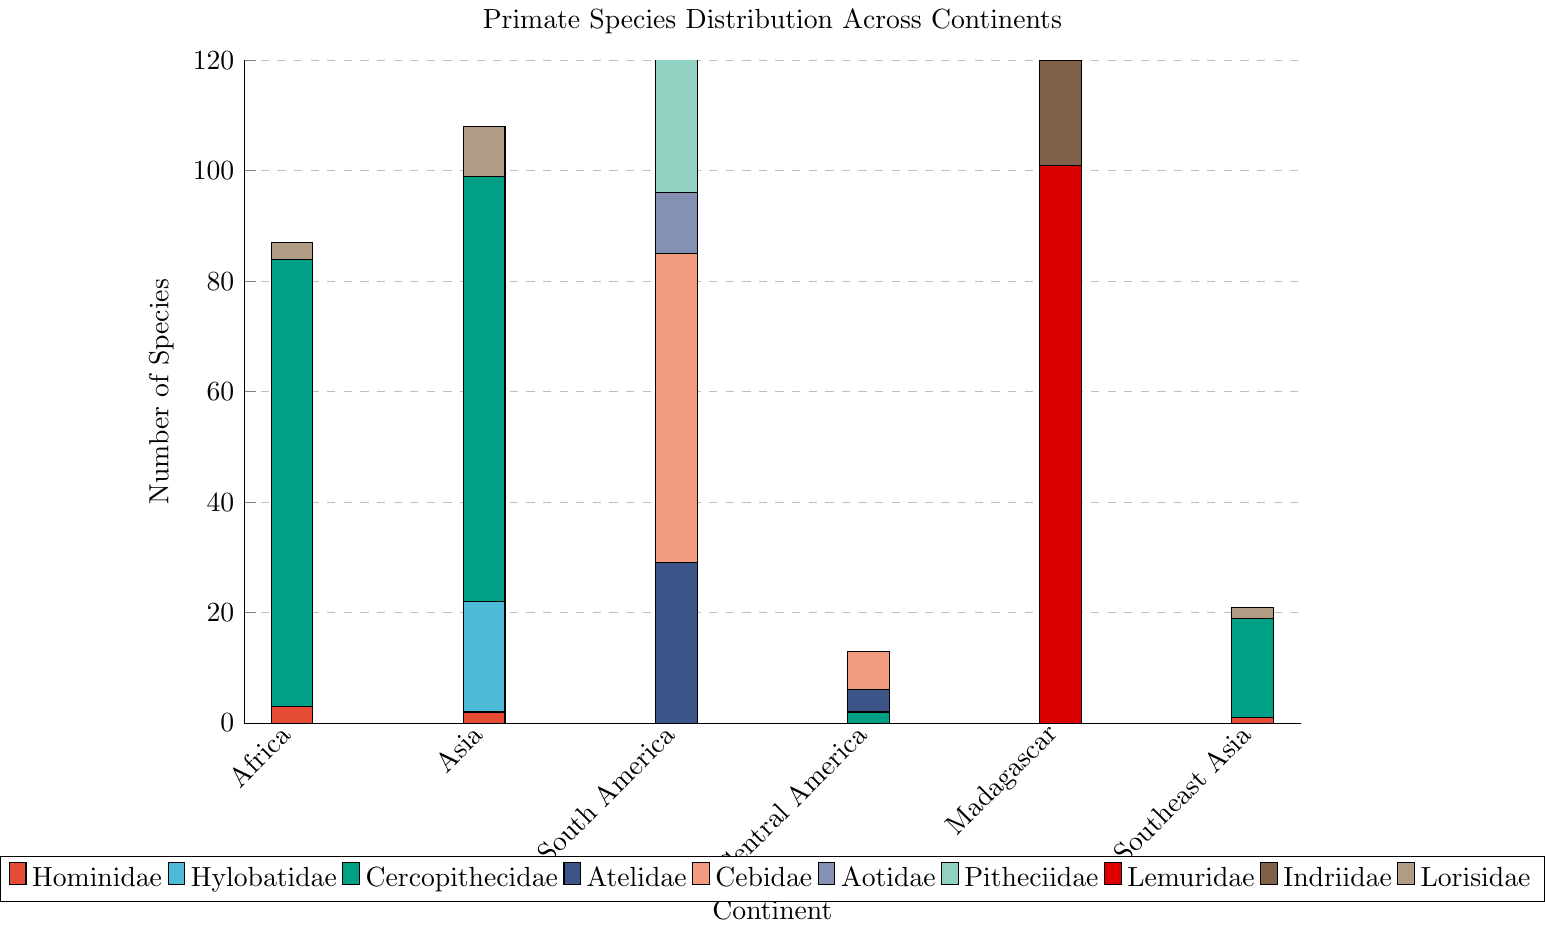What continent has the highest number of Cercopithecidae species? By examining the bar heights representing Cercopithecidae species on the chart, Africa has the highest bar, indicating it has the largest number of Cercopithecidae species.
Answer: Africa Which continent has more species of the Hylobatidae family, Africa or Asia? Comparing the bars for Hylobatidae in Africa and Asia, Africa’s bar height is zero while Asia’s bar height is 20, indicating Asia has more species.
Answer: Asia How many Lorisidae species are found in Southeast Asia? The height of the bar representing Lorisidae species in Southeast Asia is 2, indicating there are 2 species.
Answer: 2 What's the total number of species in the family Lemuridae and Indriidae found in Madagascar? Summing the heights of the Lemuridae bar (101) and Indriidae bar (19) in Madagascar, the total is 101 + 19 = 120.
Answer: 120 Which continent has the least diversity in terms of different primate families represented? Central America has the least number of different families represented since it only has bars for Cercopithecidae and Cebidae, with no other families shown.
Answer: Central America How many more Hylobatidae species are there in Asia compared to the number of Hominidae species in Southeast Asia? The bar height for Hylobatidae in Asia is 20, and for Hominidae in Southeast Asia is 1. The difference is 20 - 1 = 19.
Answer: 19 What is the sum of all Atelidae and Cebidae species found in South America, Central America, and Southeast Asia? Atelidae species are 29 in South America, 4 in Central America, and 0 in Southeast Asia. Cebidae species are 56 in South America, 7 in Central America, and 0 in Southeast Asia. Summing these: 29 + 4 + 0 + 56 + 7 + 0 = 96.
Answer: 96 Which continent has a higher total number of species, Africa or Asia? Adding all the species in Africa: 3 (Hominidae) + 81 (Cercopithecidae) + 3 (Lorisidae) = 87. Adding all the species in Asia: 2 (Hominidae) + 20 (Hylobatidae) + 77 (Cercopithecidae) + 9 (Lorisidae) = 108. Asia has a higher total number of species.
Answer: Asia What is the average number of species per family in Madagascar? Madagascar has 120 species from 3 families (Lemuridae, Indriidae, and Lorisidae). The average is 120 / 3 = 40.
Answer: 40 In which continent does the Cercopithecidae family have the smallest representation, and what is its number? Southeast Asia has the smallest representation of the Cercopithecidae family with a bar height of 18.
Answer: Southeast Asia, 18 